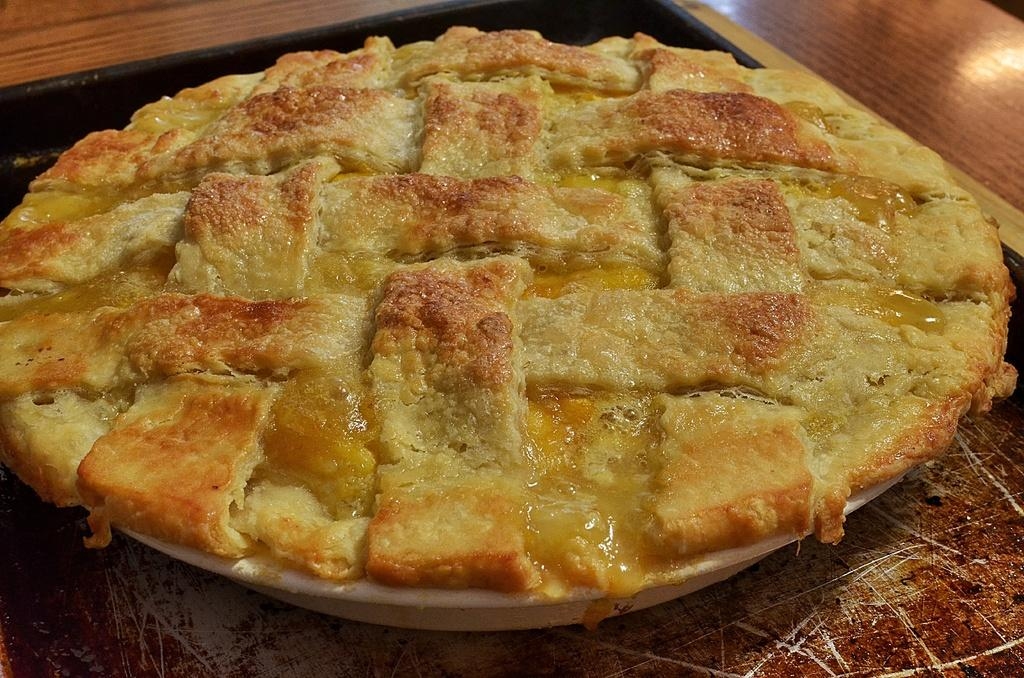What is on the white plate in the image? The white plate contains apple pie. What is the color of the table on which the plate is placed? The plate is placed on a brown table. What color is the background of the image? The background of the image is brown. What type of wire is used to hold the apple pie in place on the plate? There is no wire present in the image; the apple pie is simply placed on the plate. 